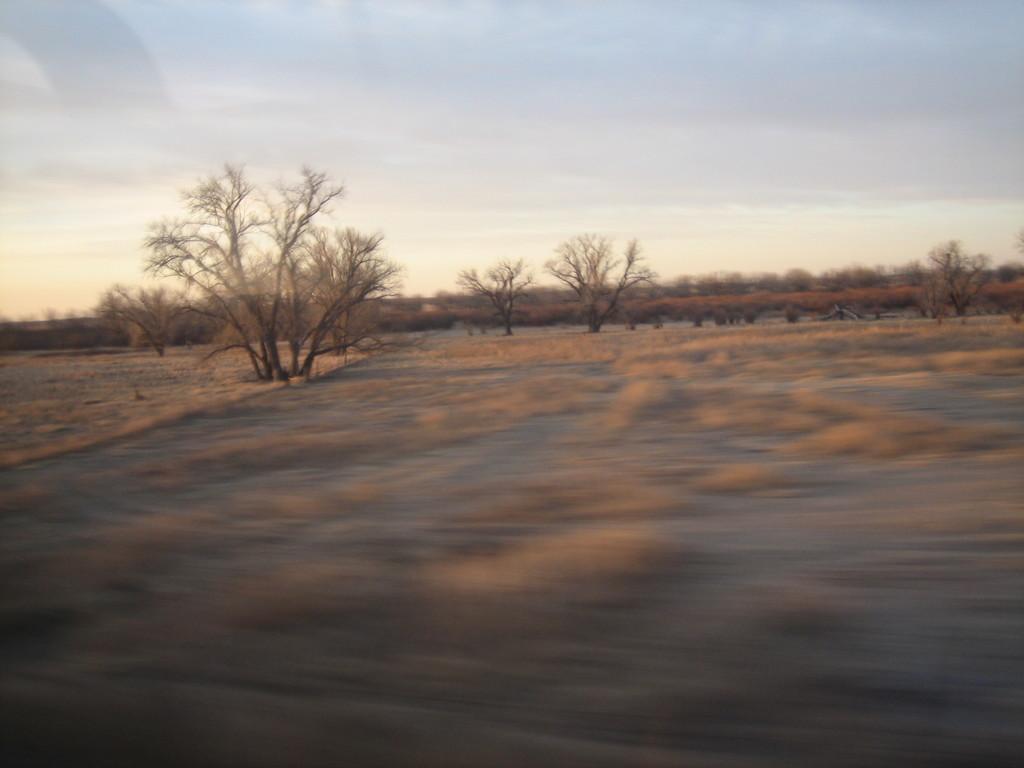Could you give a brief overview of what you see in this image? It is a blur image. In this image, we can see trees, plants and sky. 